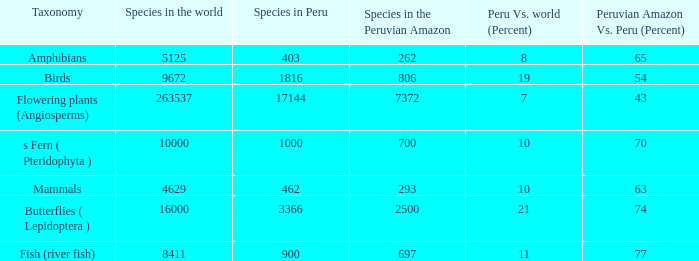What's the minimum species in the peruvian amazon with taxonomy s fern ( pteridophyta ) 700.0. 